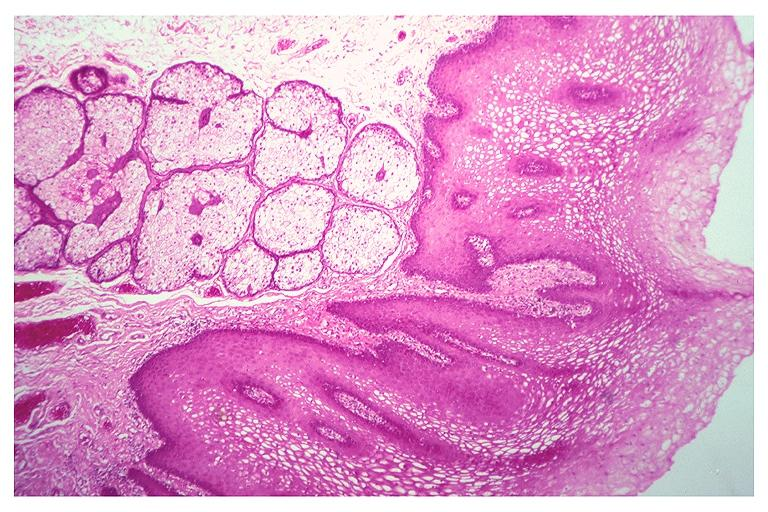does histoplasmosis show fordyce granules?
Answer the question using a single word or phrase. No 